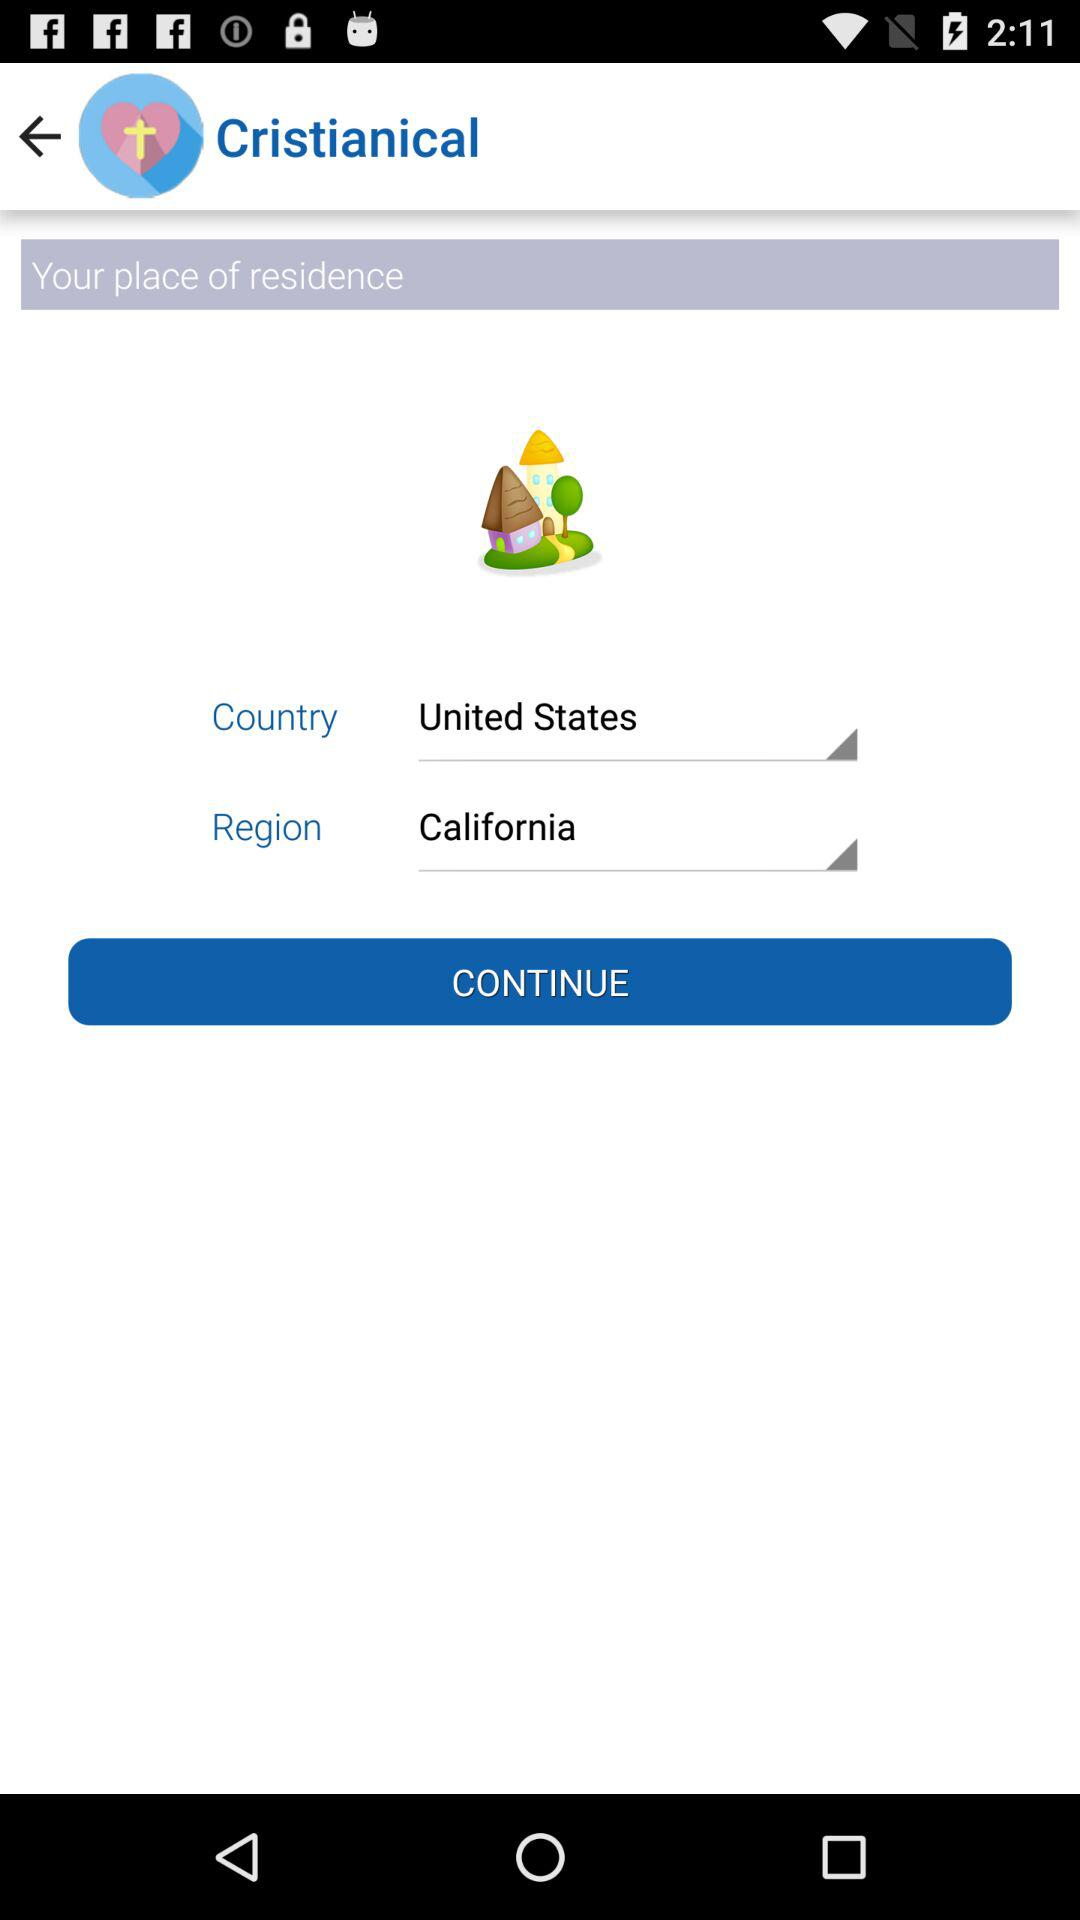What is the region? The region is California. 